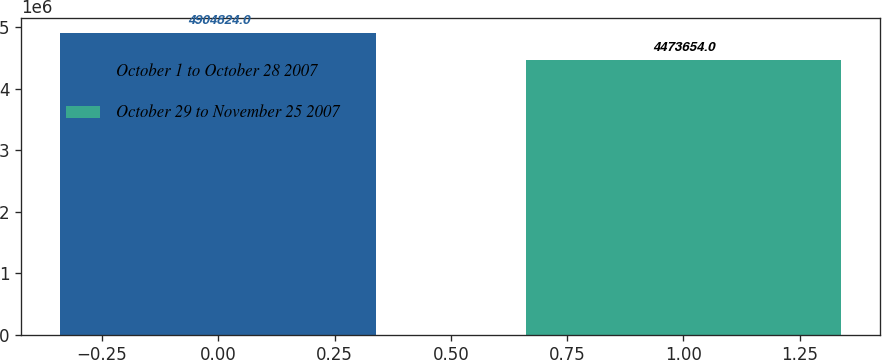Convert chart. <chart><loc_0><loc_0><loc_500><loc_500><bar_chart><fcel>October 1 to October 28 2007<fcel>October 29 to November 25 2007<nl><fcel>4.90482e+06<fcel>4.47365e+06<nl></chart> 